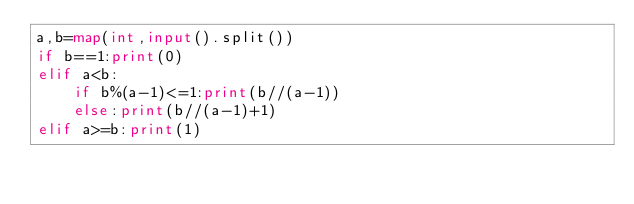Convert code to text. <code><loc_0><loc_0><loc_500><loc_500><_Python_>a,b=map(int,input().split())
if b==1:print(0)
elif a<b:
    if b%(a-1)<=1:print(b//(a-1))
    else:print(b//(a-1)+1)
elif a>=b:print(1)</code> 